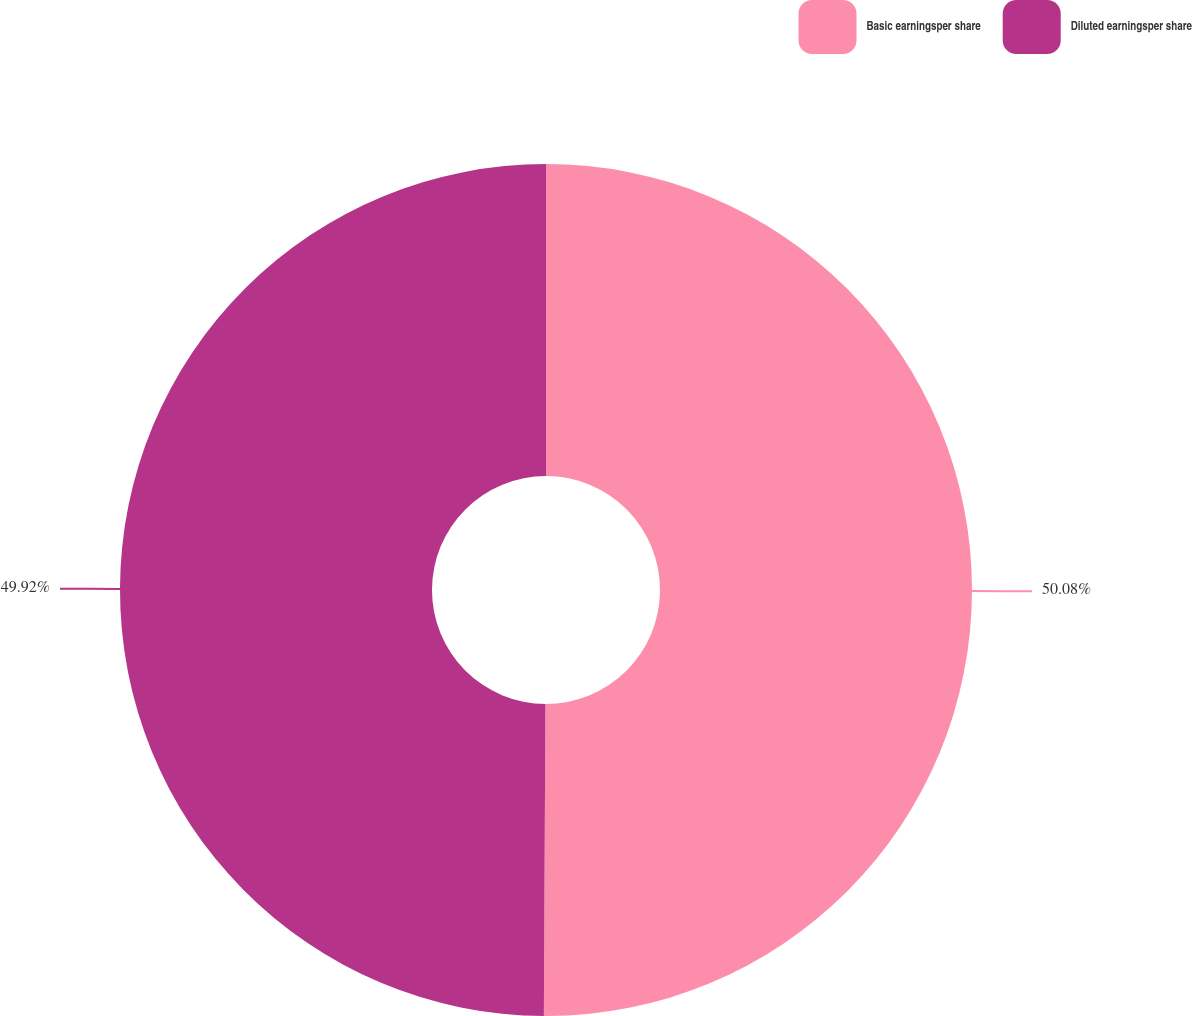Convert chart. <chart><loc_0><loc_0><loc_500><loc_500><pie_chart><fcel>Basic earningsper share<fcel>Diluted earningsper share<nl><fcel>50.08%<fcel>49.92%<nl></chart> 